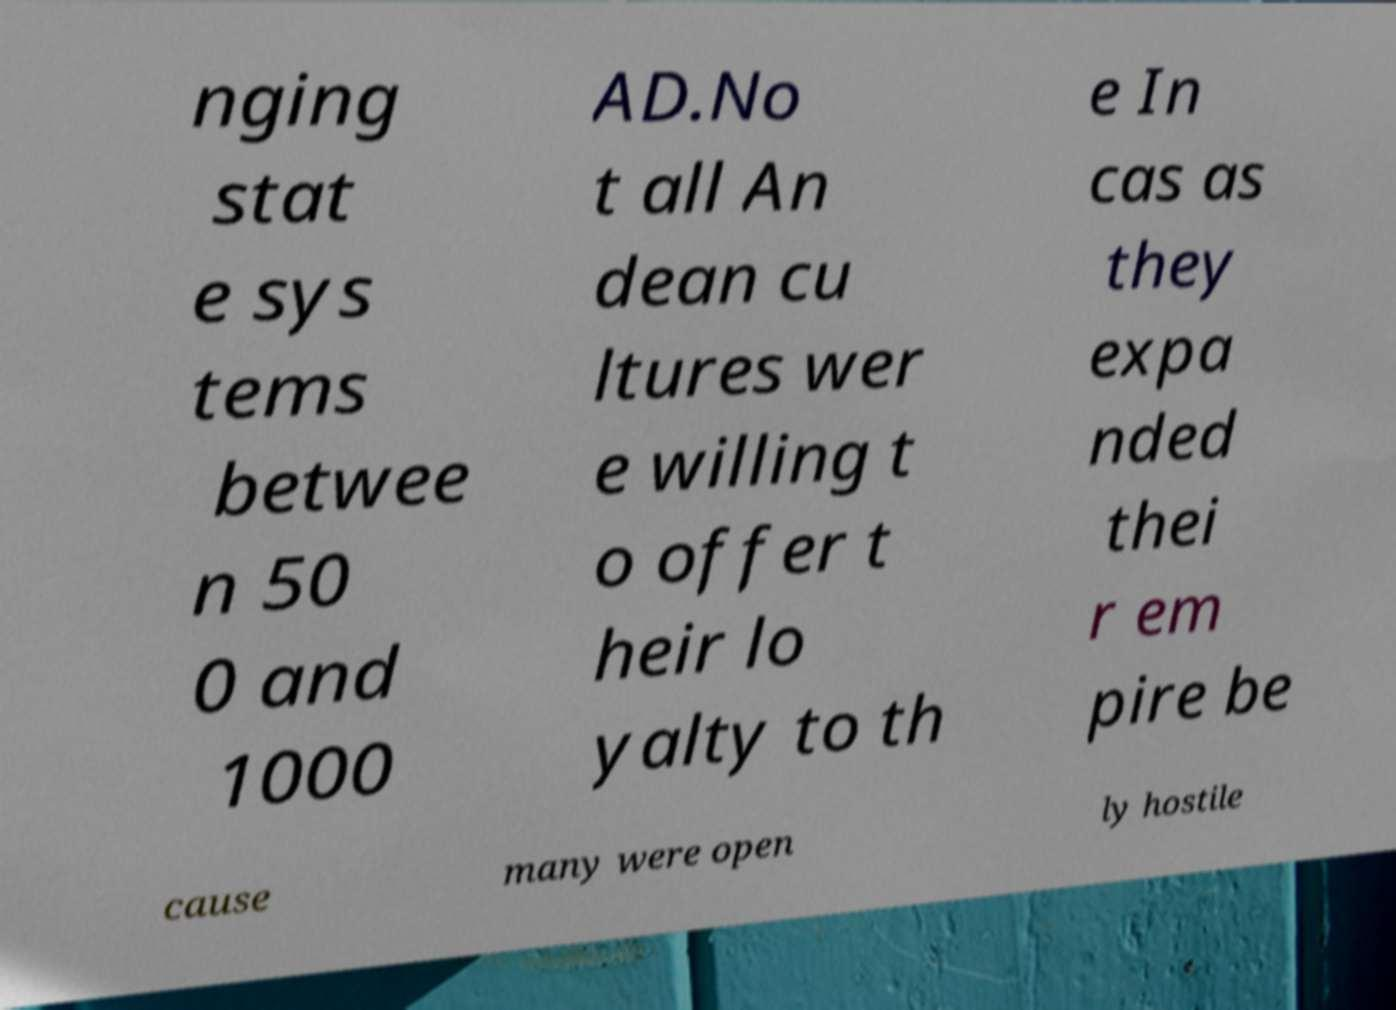Can you read and provide the text displayed in the image?This photo seems to have some interesting text. Can you extract and type it out for me? nging stat e sys tems betwee n 50 0 and 1000 AD.No t all An dean cu ltures wer e willing t o offer t heir lo yalty to th e In cas as they expa nded thei r em pire be cause many were open ly hostile 